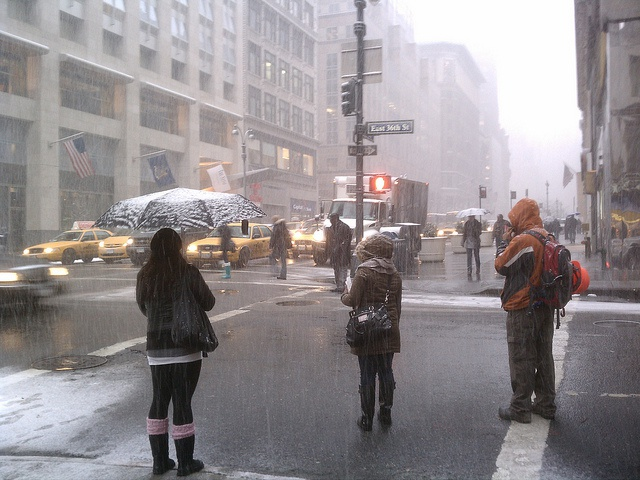Describe the objects in this image and their specific colors. I can see people in darkgray, black, and gray tones, people in darkgray, black, maroon, gray, and brown tones, people in darkgray, black, and gray tones, umbrella in darkgray, lightgray, and gray tones, and truck in darkgray, gray, and lightgray tones in this image. 